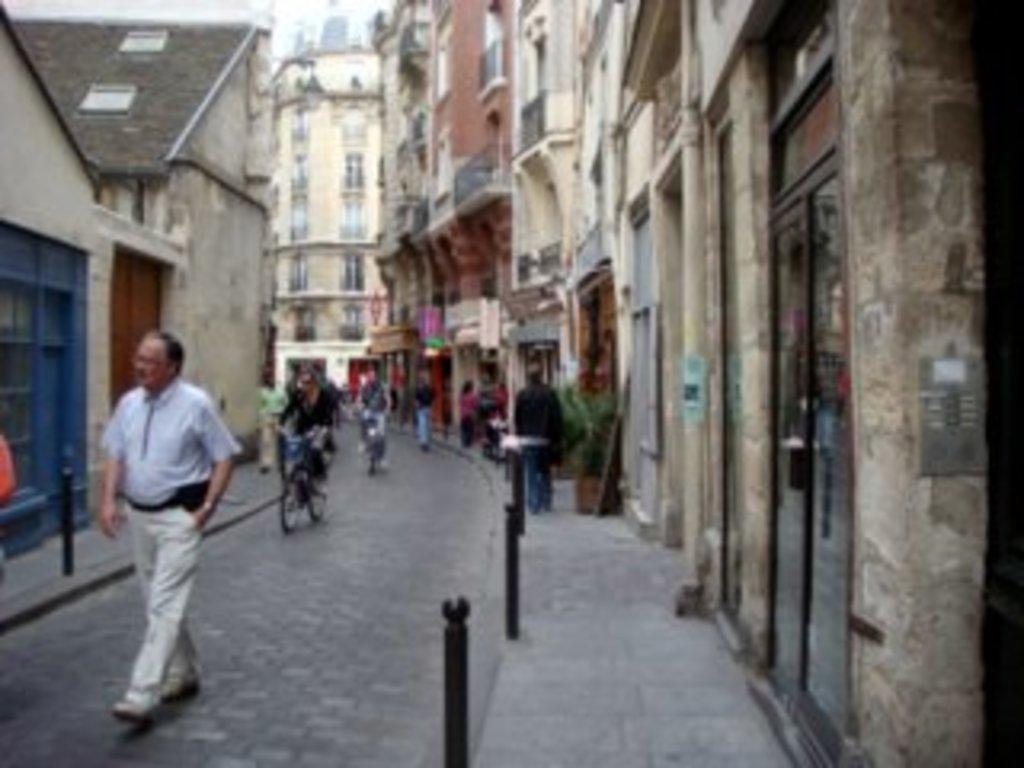Describe this image in one or two sentences. In this picture we can see some people walking on the road and some people riding bicycles, beside this road we can see metal poles, buildings and some objects. 